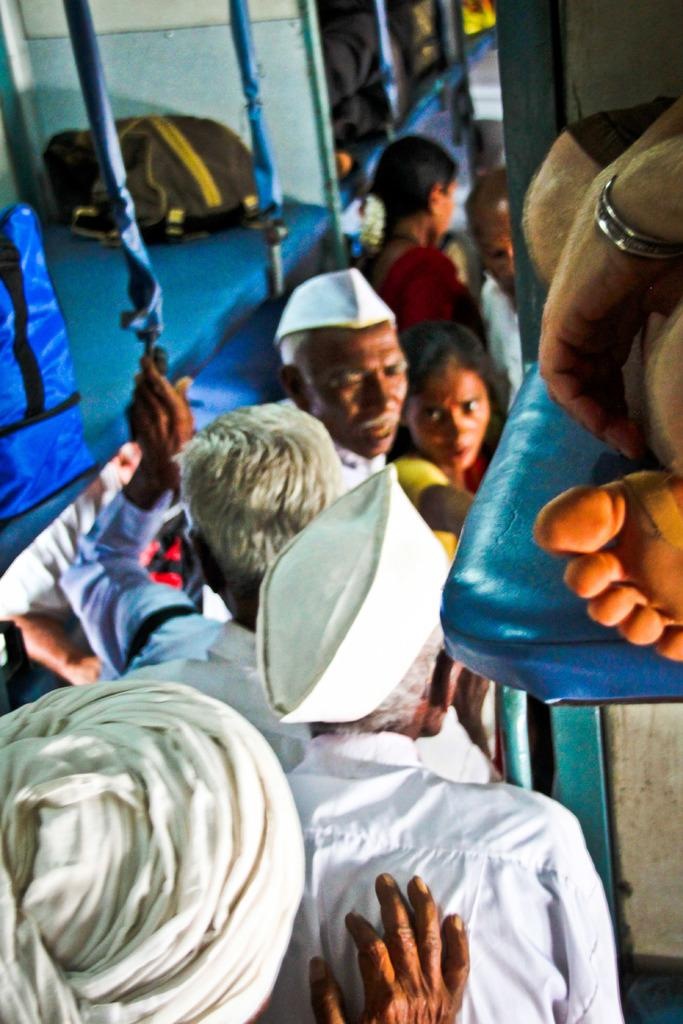What type of location is depicted in the image? The image shows an inside view of a train. What are the people in the image doing? The people in the image are standing. What are the people wearing in the image? The people are wearing white dresses and caps. What type of fear can be seen on the people's faces in the image? There is no indication of fear on the people's faces in the image; they appear to be standing normally. What thoughts are the people having in the image? We cannot determine the thoughts of the people in the image based on their facial expressions or body language. 